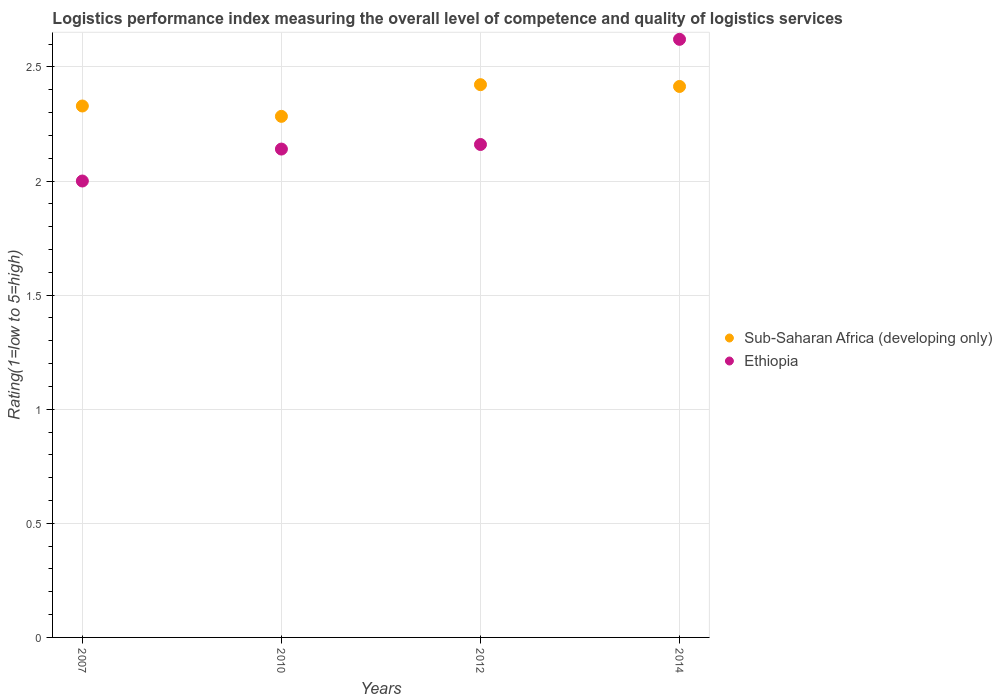How many different coloured dotlines are there?
Ensure brevity in your answer.  2. What is the Logistic performance index in Ethiopia in 2010?
Ensure brevity in your answer.  2.14. Across all years, what is the maximum Logistic performance index in Sub-Saharan Africa (developing only)?
Provide a succinct answer. 2.42. Across all years, what is the minimum Logistic performance index in Sub-Saharan Africa (developing only)?
Give a very brief answer. 2.28. In which year was the Logistic performance index in Sub-Saharan Africa (developing only) minimum?
Your response must be concise. 2010. What is the total Logistic performance index in Sub-Saharan Africa (developing only) in the graph?
Keep it short and to the point. 9.45. What is the difference between the Logistic performance index in Sub-Saharan Africa (developing only) in 2010 and that in 2014?
Your answer should be compact. -0.13. What is the difference between the Logistic performance index in Ethiopia in 2014 and the Logistic performance index in Sub-Saharan Africa (developing only) in 2012?
Your answer should be very brief. 0.2. What is the average Logistic performance index in Sub-Saharan Africa (developing only) per year?
Your answer should be compact. 2.36. In the year 2007, what is the difference between the Logistic performance index in Ethiopia and Logistic performance index in Sub-Saharan Africa (developing only)?
Your response must be concise. -0.33. What is the ratio of the Logistic performance index in Sub-Saharan Africa (developing only) in 2010 to that in 2014?
Provide a short and direct response. 0.95. What is the difference between the highest and the second highest Logistic performance index in Sub-Saharan Africa (developing only)?
Your answer should be very brief. 0.01. What is the difference between the highest and the lowest Logistic performance index in Ethiopia?
Your answer should be compact. 0.62. Is the sum of the Logistic performance index in Sub-Saharan Africa (developing only) in 2007 and 2012 greater than the maximum Logistic performance index in Ethiopia across all years?
Your answer should be compact. Yes. Does the Logistic performance index in Ethiopia monotonically increase over the years?
Your answer should be compact. Yes. Is the Logistic performance index in Ethiopia strictly less than the Logistic performance index in Sub-Saharan Africa (developing only) over the years?
Make the answer very short. No. How many years are there in the graph?
Keep it short and to the point. 4. Are the values on the major ticks of Y-axis written in scientific E-notation?
Offer a very short reply. No. How many legend labels are there?
Your answer should be very brief. 2. What is the title of the graph?
Make the answer very short. Logistics performance index measuring the overall level of competence and quality of logistics services. Does "Slovak Republic" appear as one of the legend labels in the graph?
Provide a succinct answer. No. What is the label or title of the X-axis?
Your answer should be compact. Years. What is the label or title of the Y-axis?
Offer a terse response. Rating(1=low to 5=high). What is the Rating(1=low to 5=high) in Sub-Saharan Africa (developing only) in 2007?
Your response must be concise. 2.33. What is the Rating(1=low to 5=high) in Ethiopia in 2007?
Ensure brevity in your answer.  2. What is the Rating(1=low to 5=high) in Sub-Saharan Africa (developing only) in 2010?
Give a very brief answer. 2.28. What is the Rating(1=low to 5=high) in Ethiopia in 2010?
Ensure brevity in your answer.  2.14. What is the Rating(1=low to 5=high) of Sub-Saharan Africa (developing only) in 2012?
Keep it short and to the point. 2.42. What is the Rating(1=low to 5=high) in Ethiopia in 2012?
Offer a terse response. 2.16. What is the Rating(1=low to 5=high) of Sub-Saharan Africa (developing only) in 2014?
Provide a short and direct response. 2.41. What is the Rating(1=low to 5=high) in Ethiopia in 2014?
Provide a succinct answer. 2.62. Across all years, what is the maximum Rating(1=low to 5=high) of Sub-Saharan Africa (developing only)?
Keep it short and to the point. 2.42. Across all years, what is the maximum Rating(1=low to 5=high) in Ethiopia?
Your response must be concise. 2.62. Across all years, what is the minimum Rating(1=low to 5=high) of Sub-Saharan Africa (developing only)?
Make the answer very short. 2.28. Across all years, what is the minimum Rating(1=low to 5=high) in Ethiopia?
Keep it short and to the point. 2. What is the total Rating(1=low to 5=high) of Sub-Saharan Africa (developing only) in the graph?
Keep it short and to the point. 9.45. What is the total Rating(1=low to 5=high) of Ethiopia in the graph?
Provide a succinct answer. 8.92. What is the difference between the Rating(1=low to 5=high) of Sub-Saharan Africa (developing only) in 2007 and that in 2010?
Provide a succinct answer. 0.05. What is the difference between the Rating(1=low to 5=high) in Ethiopia in 2007 and that in 2010?
Your response must be concise. -0.14. What is the difference between the Rating(1=low to 5=high) of Sub-Saharan Africa (developing only) in 2007 and that in 2012?
Provide a short and direct response. -0.09. What is the difference between the Rating(1=low to 5=high) of Ethiopia in 2007 and that in 2012?
Ensure brevity in your answer.  -0.16. What is the difference between the Rating(1=low to 5=high) of Sub-Saharan Africa (developing only) in 2007 and that in 2014?
Ensure brevity in your answer.  -0.09. What is the difference between the Rating(1=low to 5=high) of Ethiopia in 2007 and that in 2014?
Offer a terse response. -0.62. What is the difference between the Rating(1=low to 5=high) of Sub-Saharan Africa (developing only) in 2010 and that in 2012?
Your response must be concise. -0.14. What is the difference between the Rating(1=low to 5=high) of Ethiopia in 2010 and that in 2012?
Provide a short and direct response. -0.02. What is the difference between the Rating(1=low to 5=high) in Sub-Saharan Africa (developing only) in 2010 and that in 2014?
Keep it short and to the point. -0.13. What is the difference between the Rating(1=low to 5=high) of Ethiopia in 2010 and that in 2014?
Your answer should be compact. -0.48. What is the difference between the Rating(1=low to 5=high) in Sub-Saharan Africa (developing only) in 2012 and that in 2014?
Your answer should be very brief. 0.01. What is the difference between the Rating(1=low to 5=high) of Ethiopia in 2012 and that in 2014?
Provide a succinct answer. -0.46. What is the difference between the Rating(1=low to 5=high) of Sub-Saharan Africa (developing only) in 2007 and the Rating(1=low to 5=high) of Ethiopia in 2010?
Make the answer very short. 0.19. What is the difference between the Rating(1=low to 5=high) in Sub-Saharan Africa (developing only) in 2007 and the Rating(1=low to 5=high) in Ethiopia in 2012?
Give a very brief answer. 0.17. What is the difference between the Rating(1=low to 5=high) in Sub-Saharan Africa (developing only) in 2007 and the Rating(1=low to 5=high) in Ethiopia in 2014?
Keep it short and to the point. -0.29. What is the difference between the Rating(1=low to 5=high) in Sub-Saharan Africa (developing only) in 2010 and the Rating(1=low to 5=high) in Ethiopia in 2012?
Ensure brevity in your answer.  0.12. What is the difference between the Rating(1=low to 5=high) of Sub-Saharan Africa (developing only) in 2010 and the Rating(1=low to 5=high) of Ethiopia in 2014?
Your answer should be very brief. -0.34. What is the difference between the Rating(1=low to 5=high) in Sub-Saharan Africa (developing only) in 2012 and the Rating(1=low to 5=high) in Ethiopia in 2014?
Provide a short and direct response. -0.2. What is the average Rating(1=low to 5=high) of Sub-Saharan Africa (developing only) per year?
Keep it short and to the point. 2.36. What is the average Rating(1=low to 5=high) of Ethiopia per year?
Give a very brief answer. 2.23. In the year 2007, what is the difference between the Rating(1=low to 5=high) in Sub-Saharan Africa (developing only) and Rating(1=low to 5=high) in Ethiopia?
Provide a short and direct response. 0.33. In the year 2010, what is the difference between the Rating(1=low to 5=high) of Sub-Saharan Africa (developing only) and Rating(1=low to 5=high) of Ethiopia?
Make the answer very short. 0.14. In the year 2012, what is the difference between the Rating(1=low to 5=high) in Sub-Saharan Africa (developing only) and Rating(1=low to 5=high) in Ethiopia?
Offer a terse response. 0.26. In the year 2014, what is the difference between the Rating(1=low to 5=high) in Sub-Saharan Africa (developing only) and Rating(1=low to 5=high) in Ethiopia?
Make the answer very short. -0.21. What is the ratio of the Rating(1=low to 5=high) of Sub-Saharan Africa (developing only) in 2007 to that in 2010?
Your answer should be compact. 1.02. What is the ratio of the Rating(1=low to 5=high) in Ethiopia in 2007 to that in 2010?
Your answer should be very brief. 0.93. What is the ratio of the Rating(1=low to 5=high) of Sub-Saharan Africa (developing only) in 2007 to that in 2012?
Ensure brevity in your answer.  0.96. What is the ratio of the Rating(1=low to 5=high) of Ethiopia in 2007 to that in 2012?
Ensure brevity in your answer.  0.93. What is the ratio of the Rating(1=low to 5=high) of Sub-Saharan Africa (developing only) in 2007 to that in 2014?
Provide a succinct answer. 0.96. What is the ratio of the Rating(1=low to 5=high) of Ethiopia in 2007 to that in 2014?
Your answer should be compact. 0.76. What is the ratio of the Rating(1=low to 5=high) in Sub-Saharan Africa (developing only) in 2010 to that in 2012?
Your answer should be very brief. 0.94. What is the ratio of the Rating(1=low to 5=high) in Ethiopia in 2010 to that in 2012?
Keep it short and to the point. 0.99. What is the ratio of the Rating(1=low to 5=high) in Sub-Saharan Africa (developing only) in 2010 to that in 2014?
Offer a terse response. 0.95. What is the ratio of the Rating(1=low to 5=high) of Ethiopia in 2010 to that in 2014?
Provide a succinct answer. 0.82. What is the ratio of the Rating(1=low to 5=high) in Ethiopia in 2012 to that in 2014?
Make the answer very short. 0.82. What is the difference between the highest and the second highest Rating(1=low to 5=high) in Sub-Saharan Africa (developing only)?
Provide a short and direct response. 0.01. What is the difference between the highest and the second highest Rating(1=low to 5=high) of Ethiopia?
Provide a short and direct response. 0.46. What is the difference between the highest and the lowest Rating(1=low to 5=high) in Sub-Saharan Africa (developing only)?
Provide a short and direct response. 0.14. What is the difference between the highest and the lowest Rating(1=low to 5=high) in Ethiopia?
Keep it short and to the point. 0.62. 